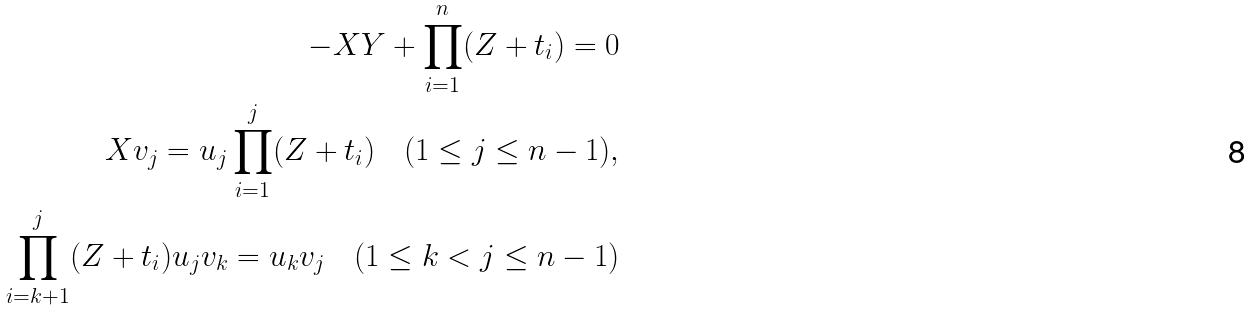<formula> <loc_0><loc_0><loc_500><loc_500>- X Y + \prod _ { i = 1 } ^ { n } ( Z + t _ { i } ) = 0 \\ X v _ { j } = u _ { j } \prod _ { i = 1 } ^ { j } ( Z + t _ { i } ) \quad ( 1 \leq j \leq n - 1 ) , \\ \prod _ { i = k + 1 } ^ { j } ( Z + t _ { i } ) u _ { j } v _ { k } = u _ { k } v _ { j } \quad ( 1 \leq k < j \leq n - 1 )</formula> 